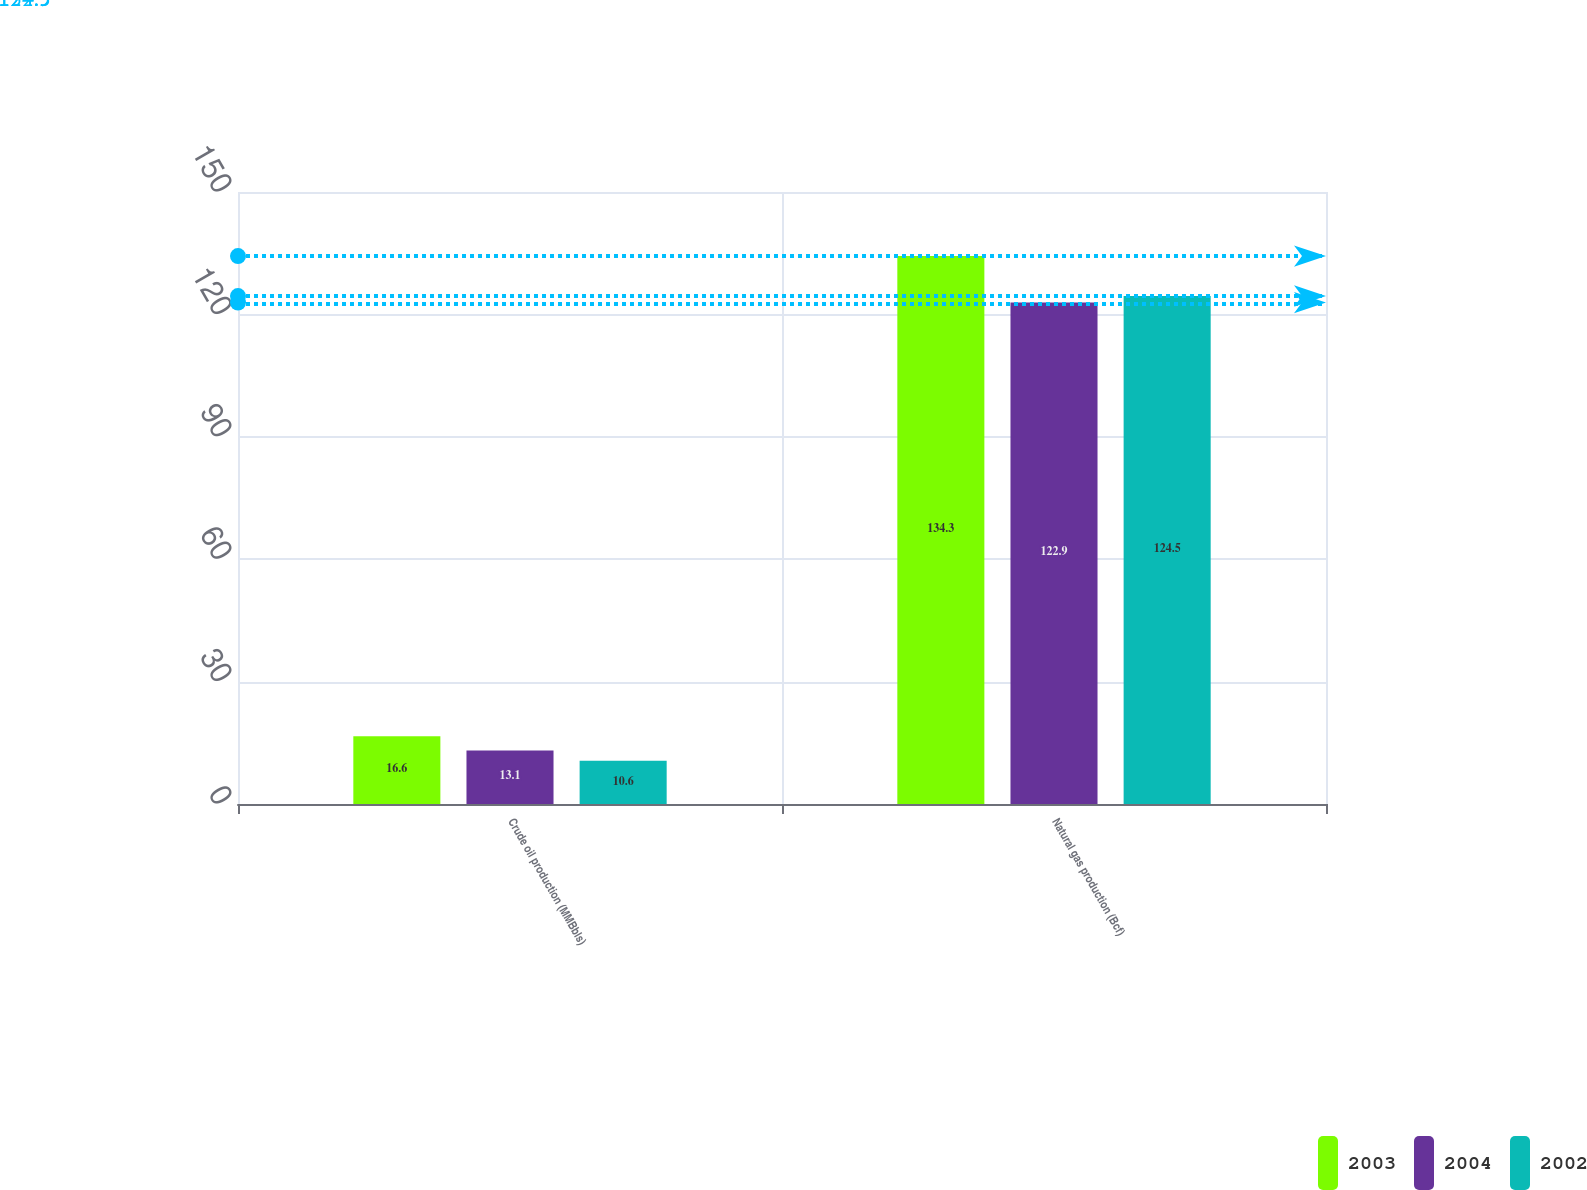Convert chart. <chart><loc_0><loc_0><loc_500><loc_500><stacked_bar_chart><ecel><fcel>Crude oil production (MMBbls)<fcel>Natural gas production (Bcf)<nl><fcel>2003<fcel>16.6<fcel>134.3<nl><fcel>2004<fcel>13.1<fcel>122.9<nl><fcel>2002<fcel>10.6<fcel>124.5<nl></chart> 